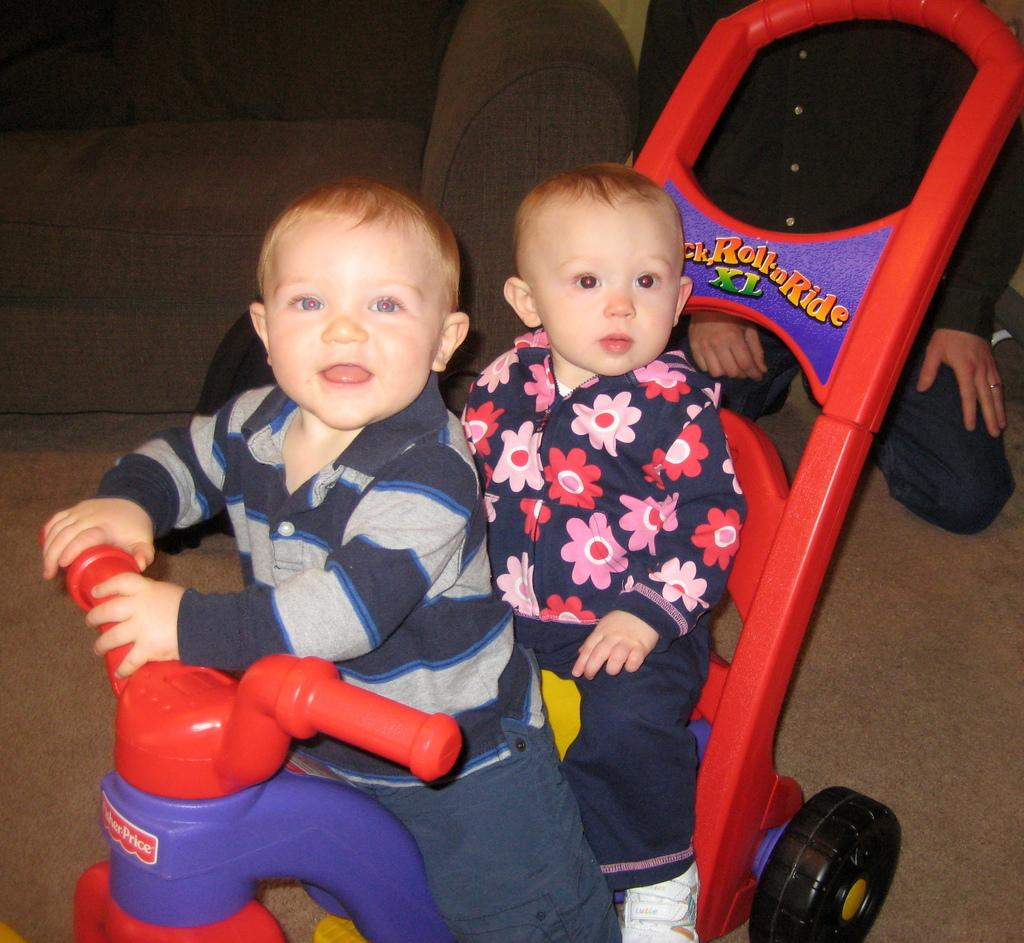How many babies are in the image? There are two babies in the image. What are the babies sitting on? The babies are sitting on a baby vehicle. What is the position of the person in the image? The person is sitting in a kneeling position on the floor. Is there any furniture visible in the image? There may be a sofa in the image. What type of drug is being administered to the birds in the image? There are no birds or drugs present in the image. 